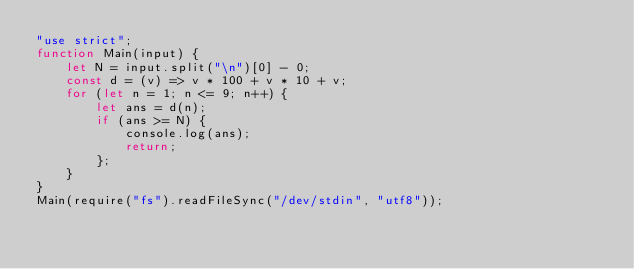<code> <loc_0><loc_0><loc_500><loc_500><_JavaScript_>"use strict";
function Main(input) {
    let N = input.split("\n")[0] - 0;
    const d = (v) => v * 100 + v * 10 + v;
    for (let n = 1; n <= 9; n++) {
        let ans = d(n);
        if (ans >= N) {
            console.log(ans);
            return;
        };
    }
}
Main(require("fs").readFileSync("/dev/stdin", "utf8"));
</code> 